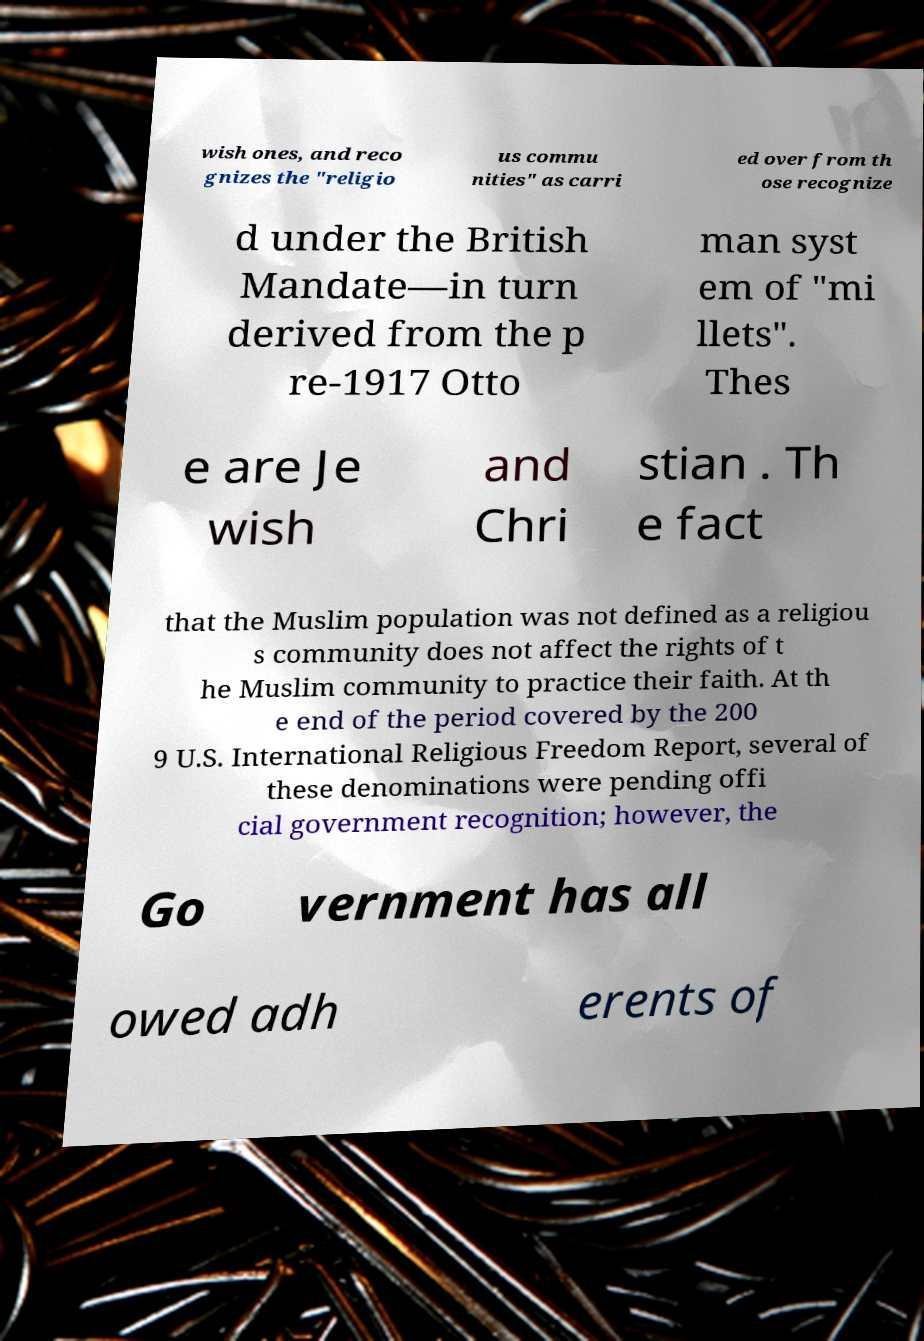Please identify and transcribe the text found in this image. wish ones, and reco gnizes the "religio us commu nities" as carri ed over from th ose recognize d under the British Mandate—in turn derived from the p re-1917 Otto man syst em of "mi llets". Thes e are Je wish and Chri stian . Th e fact that the Muslim population was not defined as a religiou s community does not affect the rights of t he Muslim community to practice their faith. At th e end of the period covered by the 200 9 U.S. International Religious Freedom Report, several of these denominations were pending offi cial government recognition; however, the Go vernment has all owed adh erents of 